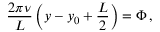Convert formula to latex. <formula><loc_0><loc_0><loc_500><loc_500>\frac { 2 \pi \nu } { L } \left ( y - y _ { 0 } + \frac { L } { 2 } \right ) = \Phi \, ,</formula> 